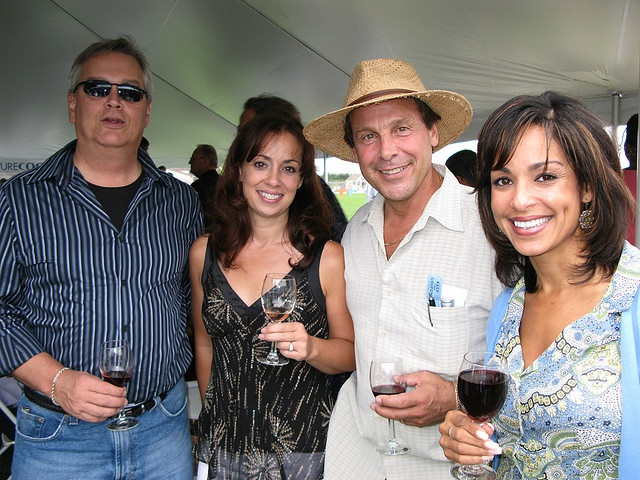Describe the objects in this image and their specific colors. I can see people in black, gray, and navy tones, people in black, lightgray, and tan tones, people in black, lightgray, brown, salmon, and darkgray tones, people in black, salmon, brown, and gray tones, and wine glass in black, gray, lightgray, and darkgray tones in this image. 